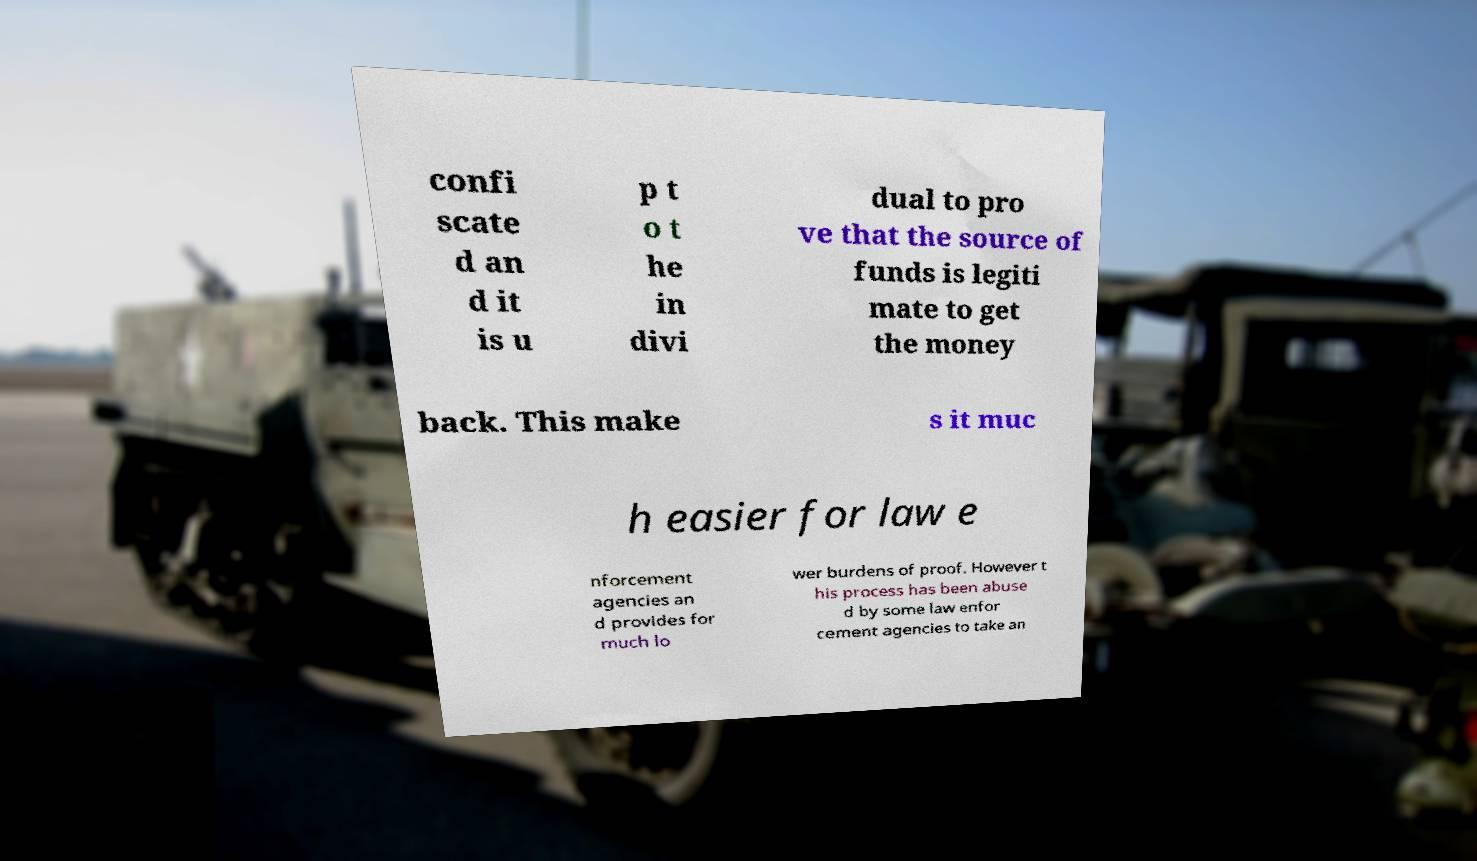Could you assist in decoding the text presented in this image and type it out clearly? confi scate d an d it is u p t o t he in divi dual to pro ve that the source of funds is legiti mate to get the money back. This make s it muc h easier for law e nforcement agencies an d provides for much lo wer burdens of proof. However t his process has been abuse d by some law enfor cement agencies to take an 